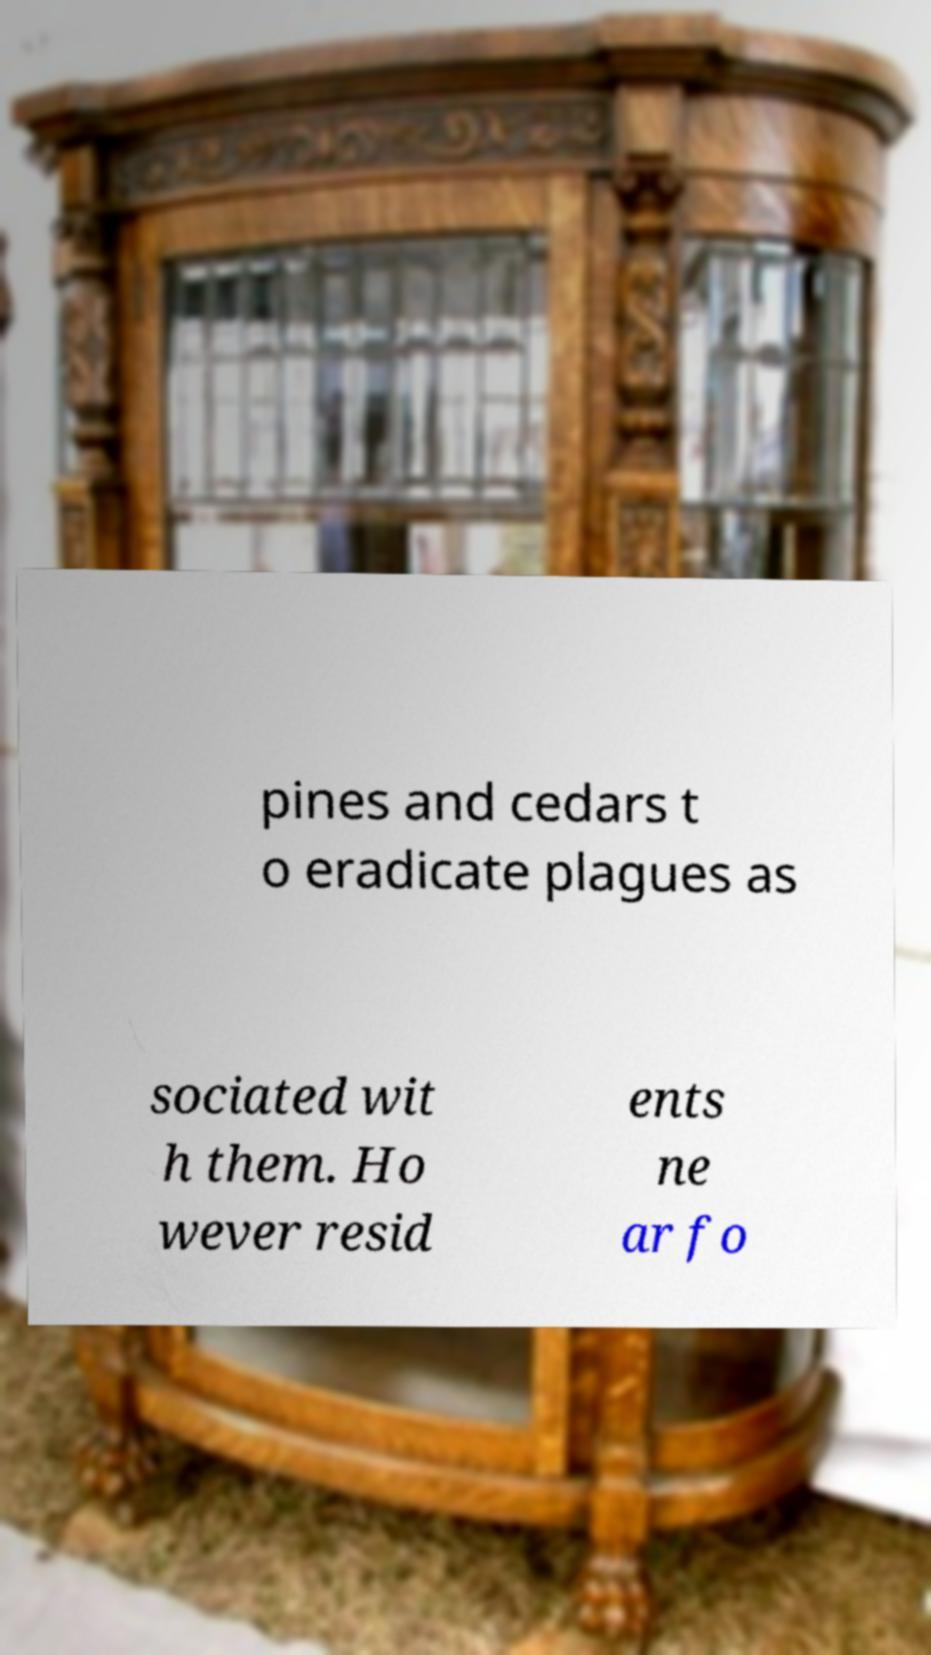Please identify and transcribe the text found in this image. pines and cedars t o eradicate plagues as sociated wit h them. Ho wever resid ents ne ar fo 